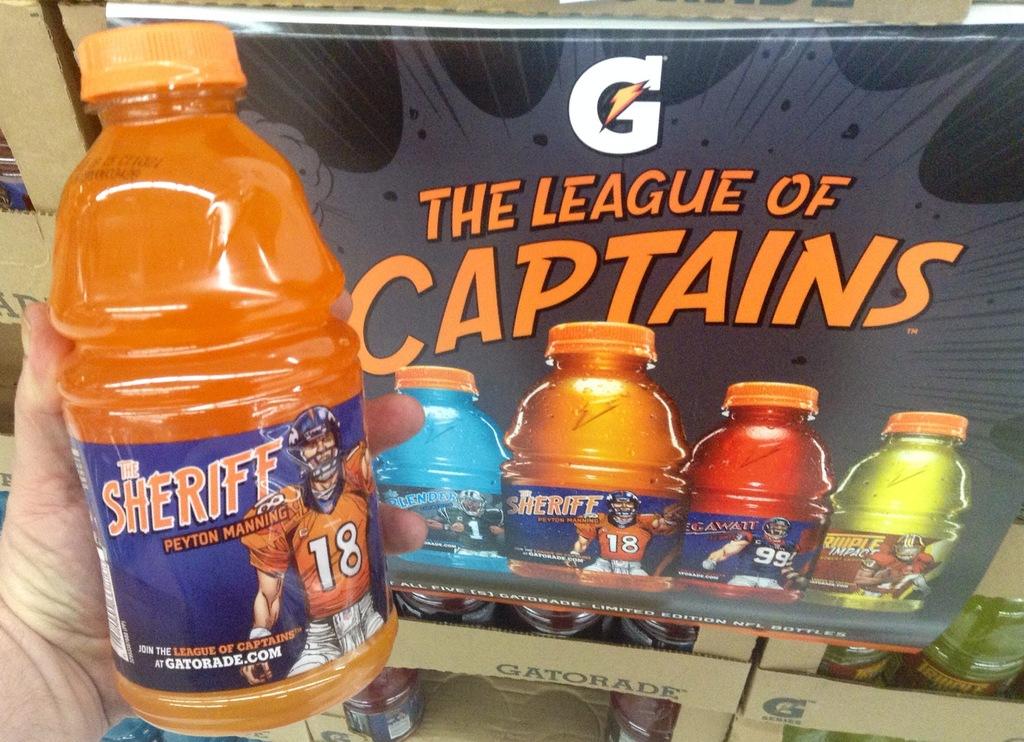Who is the orange gatorade named after?
Offer a very short reply. Peyton manning. Whose league is it?
Your response must be concise. Captains. 